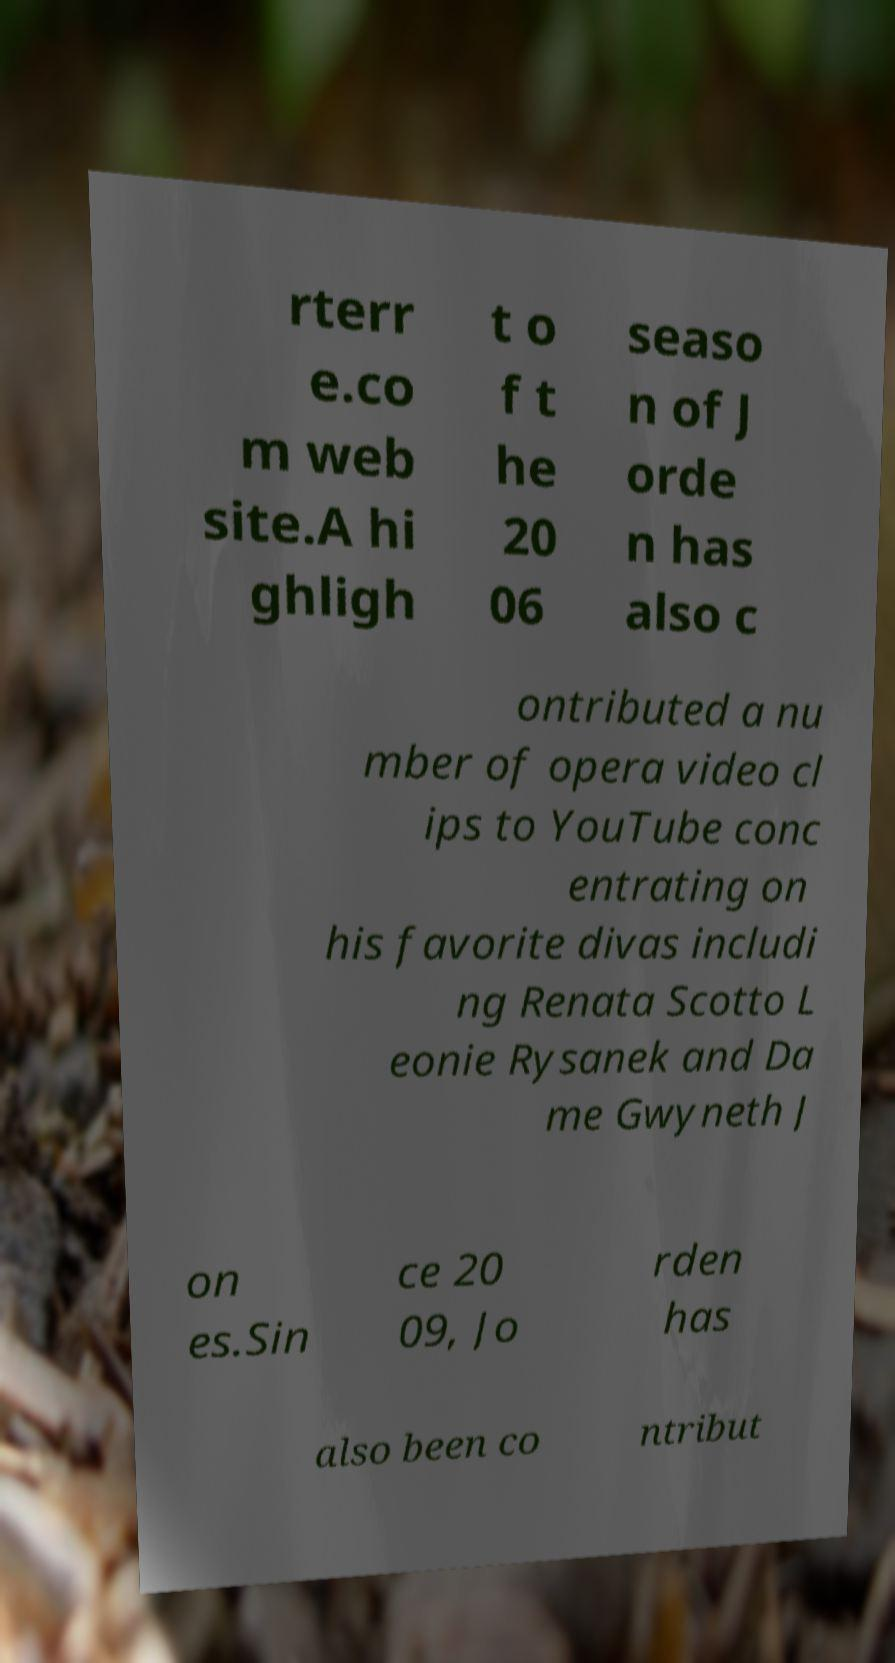There's text embedded in this image that I need extracted. Can you transcribe it verbatim? rterr e.co m web site.A hi ghligh t o f t he 20 06 seaso n of J orde n has also c ontributed a nu mber of opera video cl ips to YouTube conc entrating on his favorite divas includi ng Renata Scotto L eonie Rysanek and Da me Gwyneth J on es.Sin ce 20 09, Jo rden has also been co ntribut 